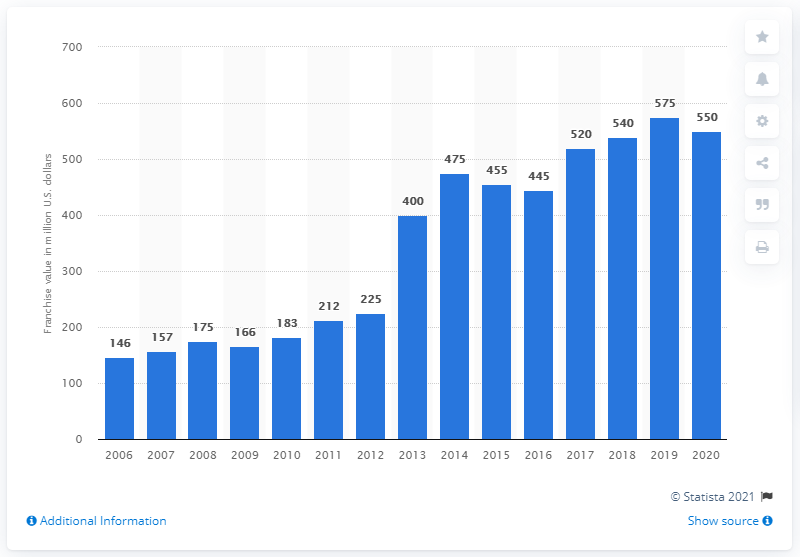Specify some key components in this picture. According to estimates, the Edmonton Oilers franchise was valued at approximately $550 million in 2020. 